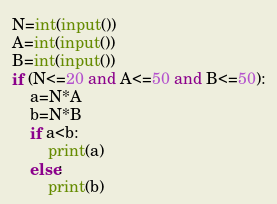Convert code to text. <code><loc_0><loc_0><loc_500><loc_500><_Python_>N=int(input())
A=int(input())
B=int(input())
if (N<=20 and A<=50 and B<=50):
    a=N*A
    b=N*B
    if a<b:
        print(a)
    else:
        print(b)</code> 